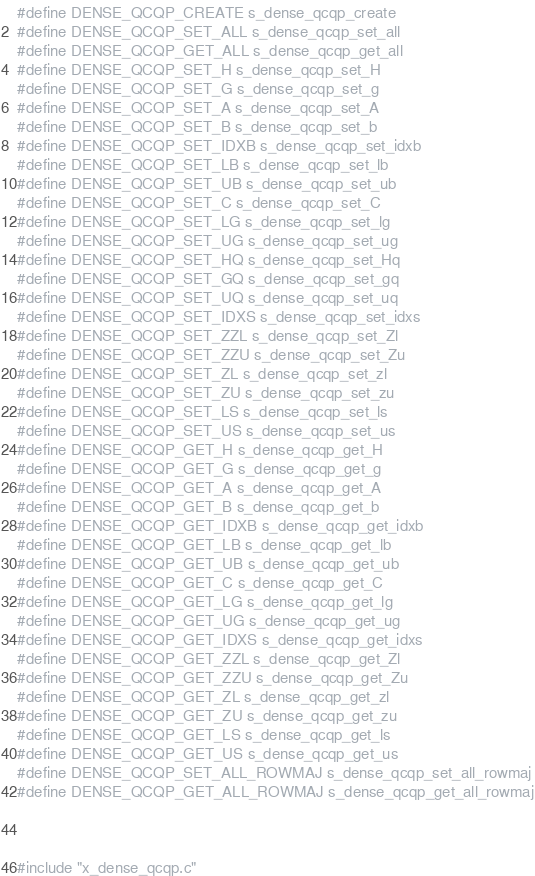Convert code to text. <code><loc_0><loc_0><loc_500><loc_500><_C_>#define DENSE_QCQP_CREATE s_dense_qcqp_create
#define DENSE_QCQP_SET_ALL s_dense_qcqp_set_all
#define DENSE_QCQP_GET_ALL s_dense_qcqp_get_all
#define DENSE_QCQP_SET_H s_dense_qcqp_set_H
#define DENSE_QCQP_SET_G s_dense_qcqp_set_g
#define DENSE_QCQP_SET_A s_dense_qcqp_set_A
#define DENSE_QCQP_SET_B s_dense_qcqp_set_b
#define DENSE_QCQP_SET_IDXB s_dense_qcqp_set_idxb
#define DENSE_QCQP_SET_LB s_dense_qcqp_set_lb
#define DENSE_QCQP_SET_UB s_dense_qcqp_set_ub
#define DENSE_QCQP_SET_C s_dense_qcqp_set_C
#define DENSE_QCQP_SET_LG s_dense_qcqp_set_lg
#define DENSE_QCQP_SET_UG s_dense_qcqp_set_ug
#define DENSE_QCQP_SET_HQ s_dense_qcqp_set_Hq
#define DENSE_QCQP_SET_GQ s_dense_qcqp_set_gq
#define DENSE_QCQP_SET_UQ s_dense_qcqp_set_uq
#define DENSE_QCQP_SET_IDXS s_dense_qcqp_set_idxs
#define DENSE_QCQP_SET_ZZL s_dense_qcqp_set_Zl
#define DENSE_QCQP_SET_ZZU s_dense_qcqp_set_Zu
#define DENSE_QCQP_SET_ZL s_dense_qcqp_set_zl
#define DENSE_QCQP_SET_ZU s_dense_qcqp_set_zu
#define DENSE_QCQP_SET_LS s_dense_qcqp_set_ls
#define DENSE_QCQP_SET_US s_dense_qcqp_set_us
#define DENSE_QCQP_GET_H s_dense_qcqp_get_H
#define DENSE_QCQP_GET_G s_dense_qcqp_get_g
#define DENSE_QCQP_GET_A s_dense_qcqp_get_A
#define DENSE_QCQP_GET_B s_dense_qcqp_get_b
#define DENSE_QCQP_GET_IDXB s_dense_qcqp_get_idxb
#define DENSE_QCQP_GET_LB s_dense_qcqp_get_lb
#define DENSE_QCQP_GET_UB s_dense_qcqp_get_ub
#define DENSE_QCQP_GET_C s_dense_qcqp_get_C
#define DENSE_QCQP_GET_LG s_dense_qcqp_get_lg
#define DENSE_QCQP_GET_UG s_dense_qcqp_get_ug
#define DENSE_QCQP_GET_IDXS s_dense_qcqp_get_idxs
#define DENSE_QCQP_GET_ZZL s_dense_qcqp_get_Zl
#define DENSE_QCQP_GET_ZZU s_dense_qcqp_get_Zu
#define DENSE_QCQP_GET_ZL s_dense_qcqp_get_zl
#define DENSE_QCQP_GET_ZU s_dense_qcqp_get_zu
#define DENSE_QCQP_GET_LS s_dense_qcqp_get_ls
#define DENSE_QCQP_GET_US s_dense_qcqp_get_us
#define DENSE_QCQP_SET_ALL_ROWMAJ s_dense_qcqp_set_all_rowmaj
#define DENSE_QCQP_GET_ALL_ROWMAJ s_dense_qcqp_get_all_rowmaj



#include "x_dense_qcqp.c"


</code> 